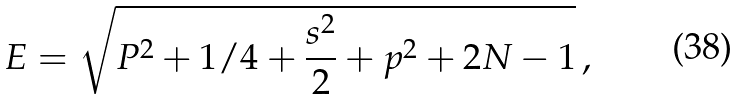<formula> <loc_0><loc_0><loc_500><loc_500>E = \sqrt { P ^ { 2 } + 1 / 4 + \frac { s ^ { 2 } } { 2 } + p ^ { 2 } + 2 N - 1 } \, ,</formula> 